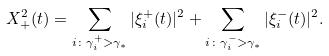Convert formula to latex. <formula><loc_0><loc_0><loc_500><loc_500>X ^ { 2 } _ { + } ( t ) = \sum _ { i \colon \gamma ^ { + } _ { i } > \gamma _ { * } } | \xi _ { i } ^ { + } ( t ) | ^ { 2 } + \sum _ { i \colon \gamma ^ { - } _ { i } > \gamma _ { * } } | \xi _ { i } ^ { - } ( t ) | ^ { 2 } .</formula> 